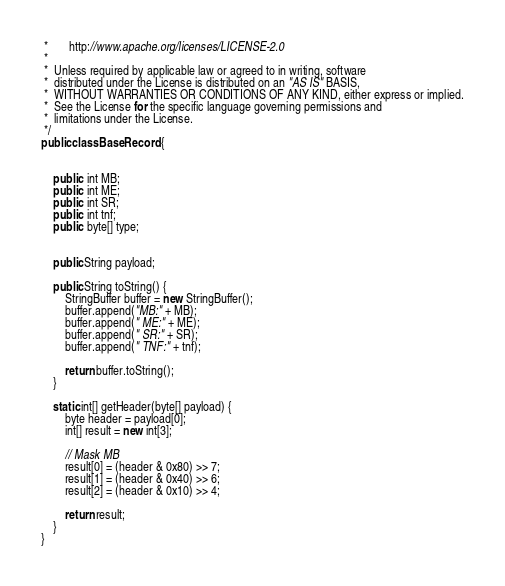Convert code to text. <code><loc_0><loc_0><loc_500><loc_500><_Java_> *       http://www.apache.org/licenses/LICENSE-2.0
 *
 *  Unless required by applicable law or agreed to in writing, software
 *  distributed under the License is distributed on an "AS IS" BASIS,
 *  WITHOUT WARRANTIES OR CONDITIONS OF ANY KIND, either express or implied.
 *  See the License for the specific language governing permissions and
 *  limitations under the License.
 */
public class BaseRecord {


    public  int MB;
    public  int ME;
    public  int SR;
    public  int tnf;
    public  byte[] type;


    public String payload;

    public String toString() {
        StringBuffer buffer = new StringBuffer();
        buffer.append("MB:" + MB);
        buffer.append(" ME:" + ME);
        buffer.append(" SR:" + SR);
        buffer.append(" TNF:" + tnf);

        return buffer.toString();
    }

    static int[] getHeader(byte[] payload) {
        byte header = payload[0];
        int[] result = new int[3];

        // Mask MB
        result[0] = (header & 0x80) >> 7;
        result[1] = (header & 0x40) >> 6;
        result[2] = (header & 0x10) >> 4;

        return result;
    }
}
</code> 